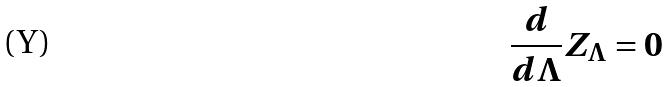Convert formula to latex. <formula><loc_0><loc_0><loc_500><loc_500>\frac { d } { d \Lambda } Z _ { \Lambda } = 0</formula> 